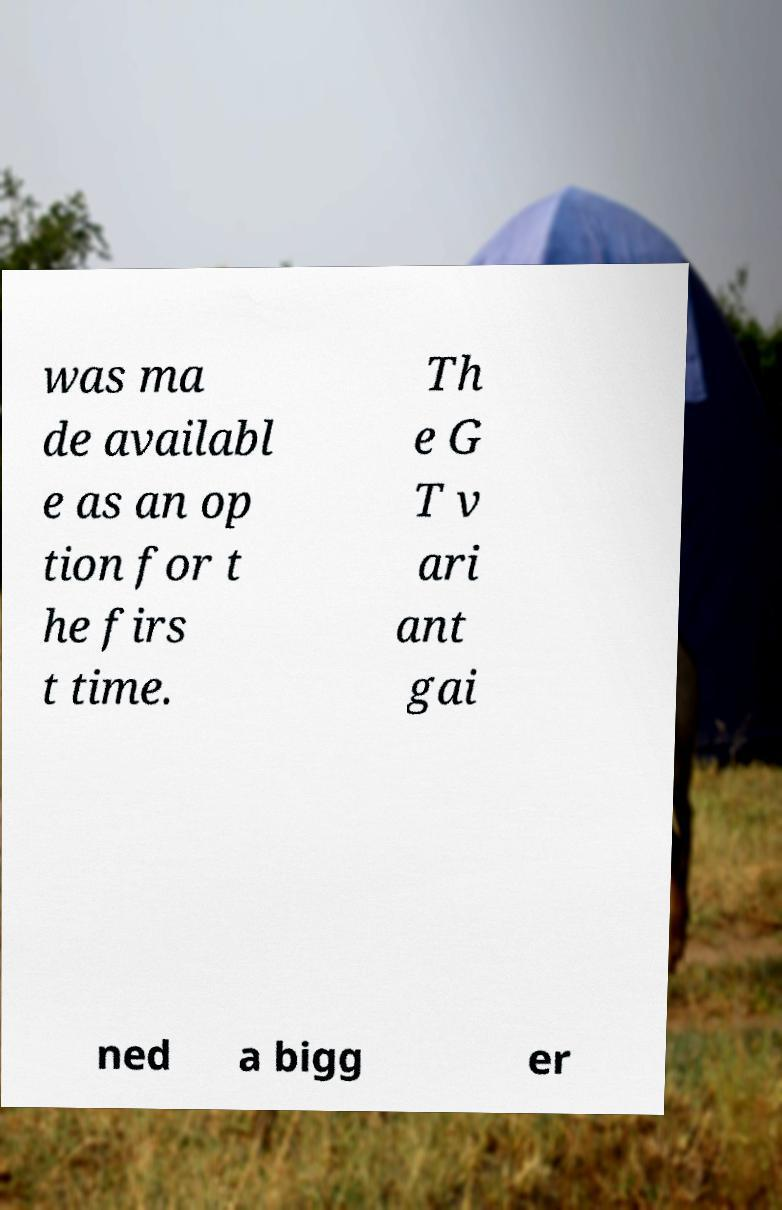I need the written content from this picture converted into text. Can you do that? was ma de availabl e as an op tion for t he firs t time. Th e G T v ari ant gai ned a bigg er 